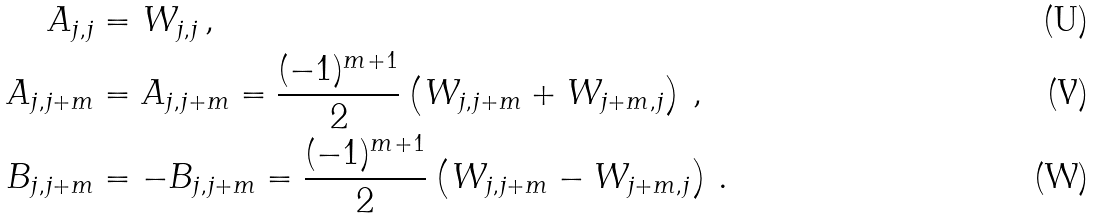<formula> <loc_0><loc_0><loc_500><loc_500>A _ { j , j } & = W _ { j , j } \, , \\ A _ { j , j + m } & = A _ { j , j + m } = \frac { ( - 1 ) ^ { m + 1 } } { 2 } \left ( W _ { j , j + m } + W _ { j + m , j } \right ) \, , \\ B _ { j , j + m } & = - B _ { j , j + m } = \frac { ( - 1 ) ^ { m + 1 } } { 2 } \left ( W _ { j , j + m } - W _ { j + m , j } \right ) \, .</formula> 